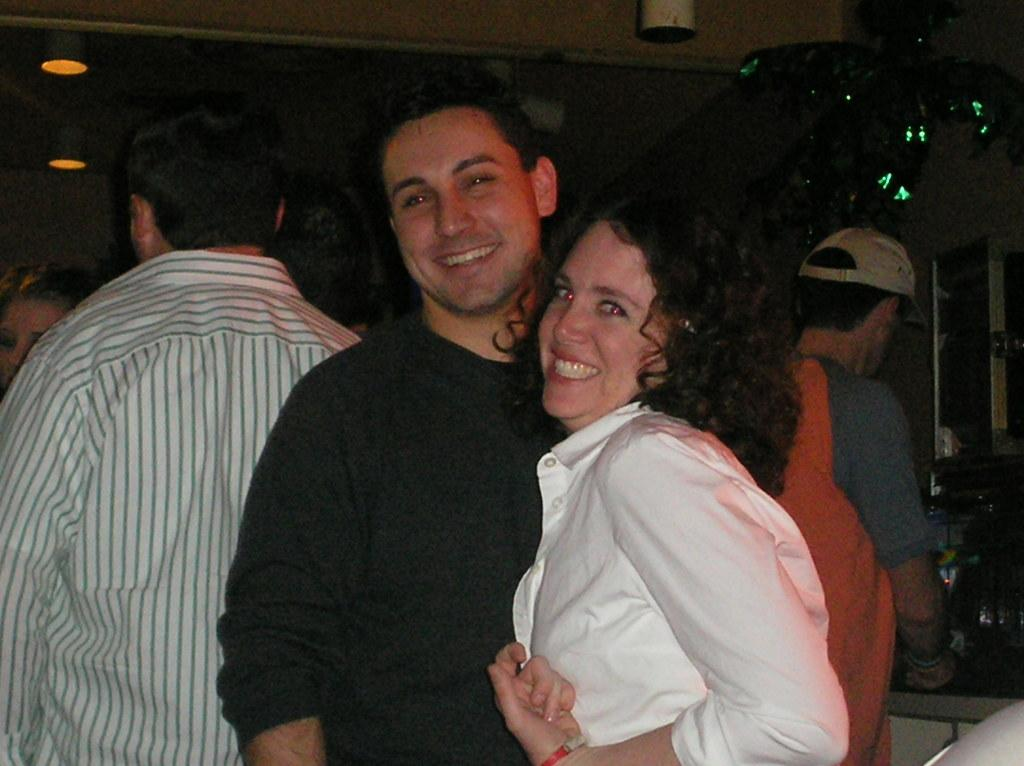How many people are standing in the image? There are people standing in the image. Can you describe the expressions of the people in the image? Two of the people are smiling. What is visible in the background of the image? There is a wall and lights in the background of the image. What type of summer activity are the people participating in the image? The provided facts do not mention any specific season or activity, so it cannot be determined from the image. Can you tell me how many ants are crawling on the wall in the image? There are no ants visible in the image. 